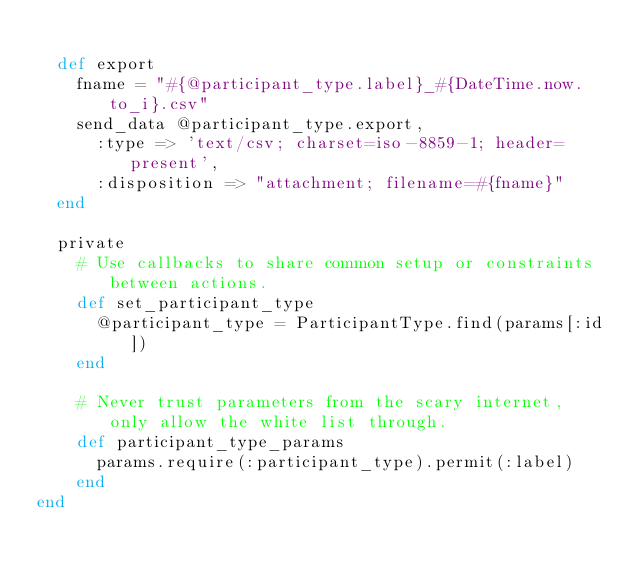<code> <loc_0><loc_0><loc_500><loc_500><_Ruby_>
  def export
    fname = "#{@participant_type.label}_#{DateTime.now.to_i}.csv"
    send_data @participant_type.export, 
      :type => 'text/csv; charset=iso-8859-1; header=present',
      :disposition => "attachment; filename=#{fname}"
  end

  private
    # Use callbacks to share common setup or constraints between actions.
    def set_participant_type
      @participant_type = ParticipantType.find(params[:id])
    end

    # Never trust parameters from the scary internet, only allow the white list through.
    def participant_type_params
      params.require(:participant_type).permit(:label)
    end
end
</code> 